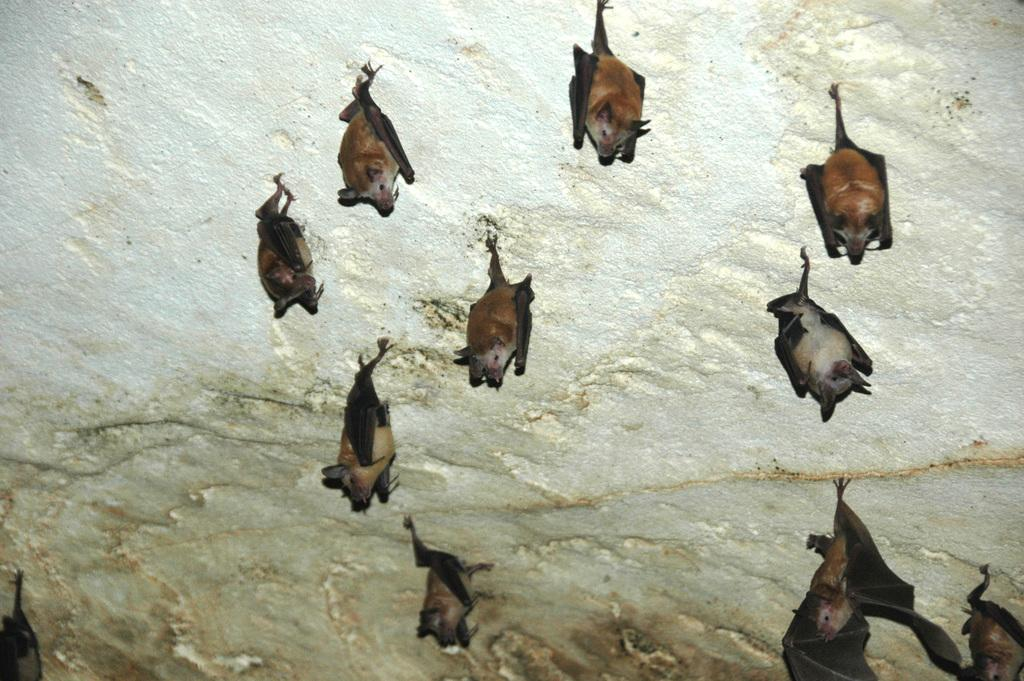What type of animals are in the image? There are bats in the image. Where are the bats located? The bats are on a platform. What type of activity are the bats participating in on the platform? The image does not show the bats participating in any specific activity on the platform. Can you see a nest for the bats in the image? There is no nest visible in the image. 